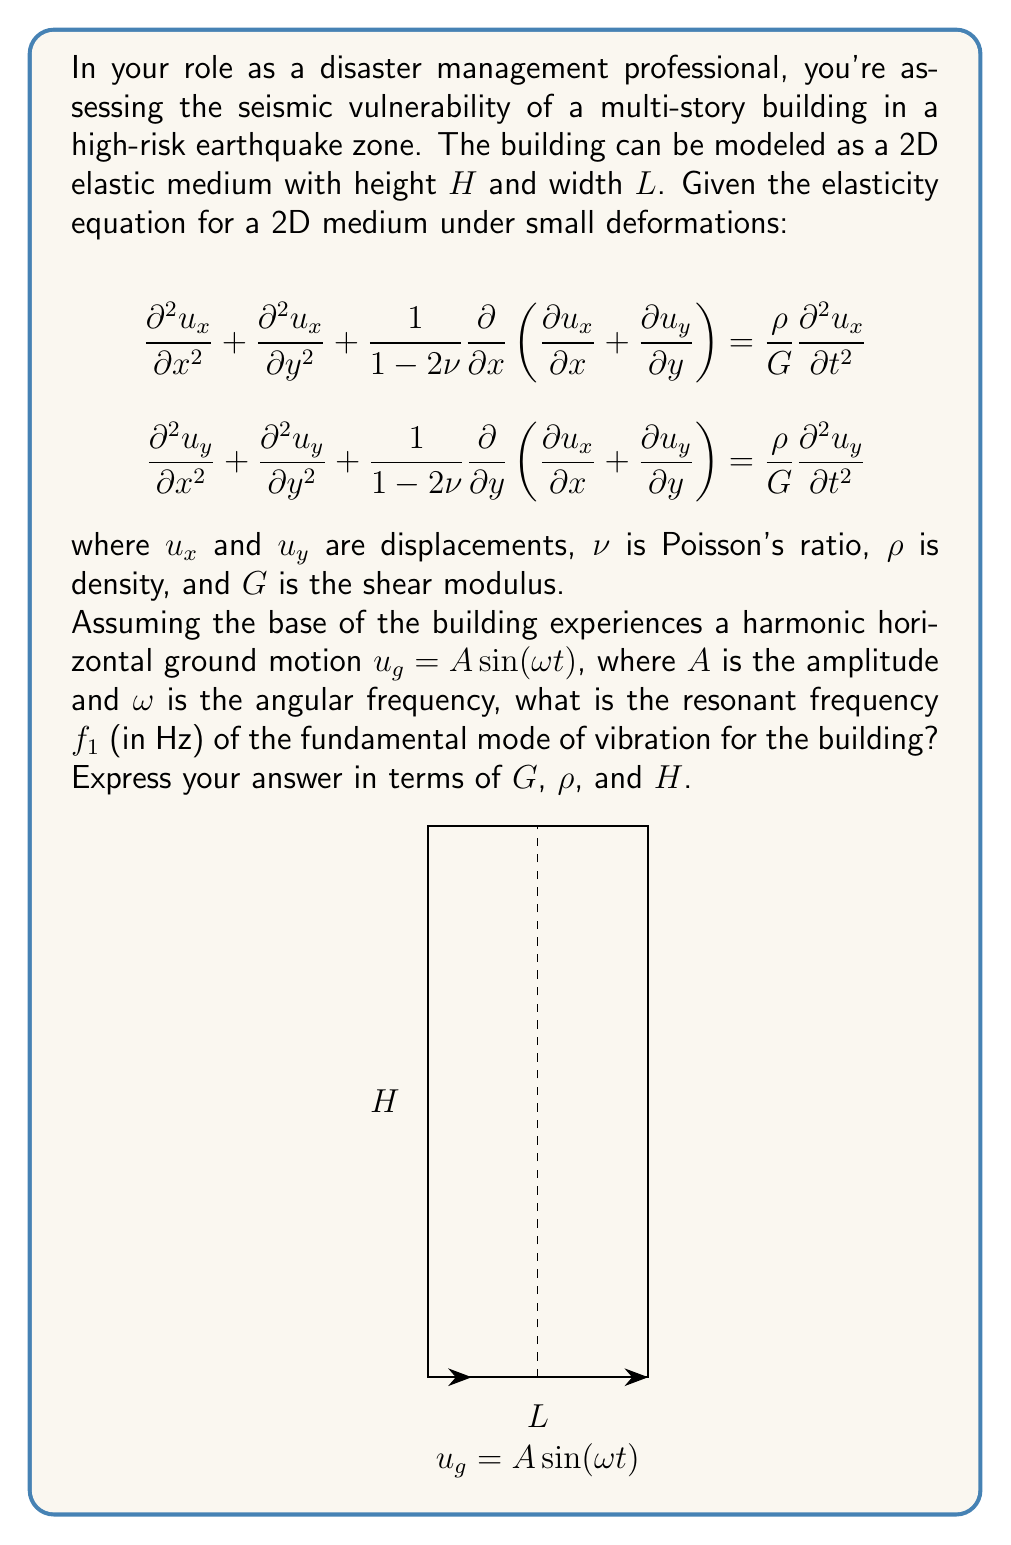Can you answer this question? To solve this problem, we'll follow these steps:

1) For the fundamental mode of vibration, we can approximate the building as a simple shear beam. This assumes that the horizontal floors are rigid and the vertical elements (columns, walls) deform in shear.

2) The equation of motion for a shear beam is:

   $$G \frac{\partial^2 u}{\partial y^2} = \rho \frac{\partial^2 u}{\partial t^2}$$

3) For harmonic motion, we can assume a solution of the form:

   $$u(y,t) = \phi(y) \sin(\omega t)$$

4) Substituting this into the equation of motion:

   $$G \frac{d^2 \phi}{d y^2} = -\rho \omega^2 \phi$$

5) The general solution to this differential equation is:

   $$\phi(y) = A \cos(\beta y) + B \sin(\beta y)$$

   where $\beta^2 = \frac{\rho \omega^2}{G}$

6) Applying boundary conditions:
   At $y = 0$ (base): $\phi(0) = 0$
   At $y = H$ (top): $\frac{d\phi}{dy}|_{y=H} = 0$

7) These conditions lead to:

   $$\beta H = \frac{\pi}{2} + n\pi$$

   where $n = 0, 1, 2, ...$

8) For the fundamental mode (n = 0):

   $$\beta H = \frac{\pi}{2}$$

9) Substituting the expression for $\beta$:

   $$\sqrt{\frac{\rho \omega^2}{G}} H = \frac{\pi}{2}$$

10) Solving for $\omega$:

    $$\omega = \frac{\pi}{2H} \sqrt{\frac{G}{\rho}}$$

11) Converting angular frequency to frequency in Hz:

    $$f_1 = \frac{\omega}{2\pi} = \frac{1}{4H} \sqrt{\frac{G}{\rho}}$$

This is the resonant frequency of the fundamental mode of vibration for the building.
Answer: $f_1 = \frac{1}{4H} \sqrt{\frac{G}{\rho}}$ 